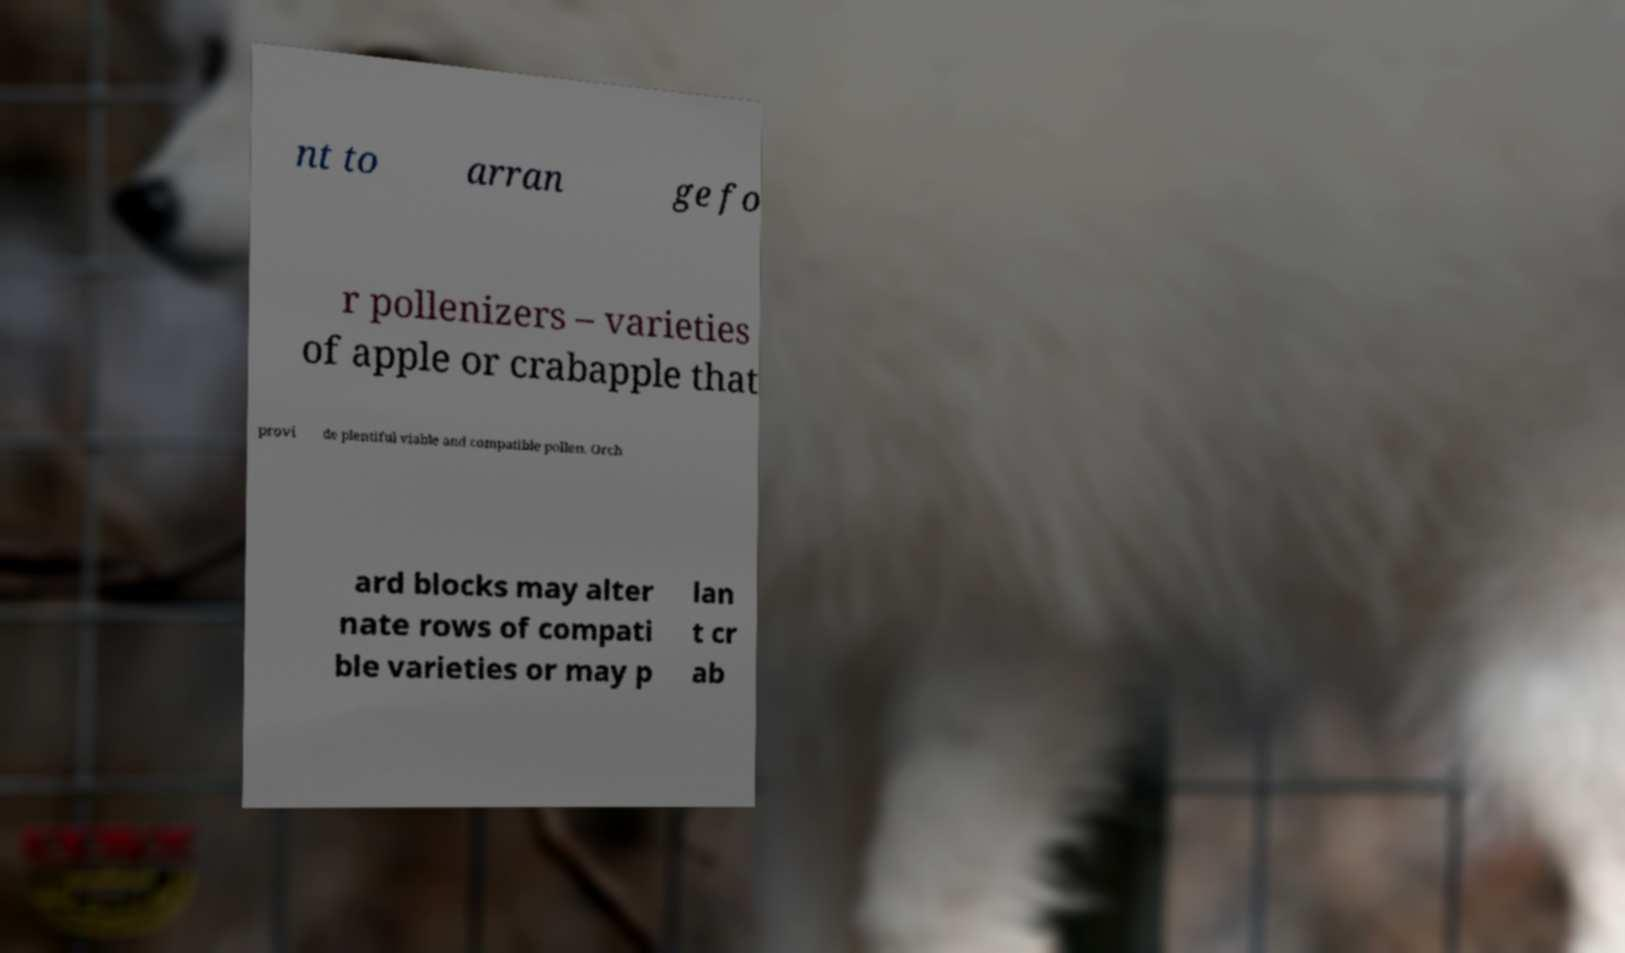Could you extract and type out the text from this image? nt to arran ge fo r pollenizers – varieties of apple or crabapple that provi de plentiful viable and compatible pollen. Orch ard blocks may alter nate rows of compati ble varieties or may p lan t cr ab 